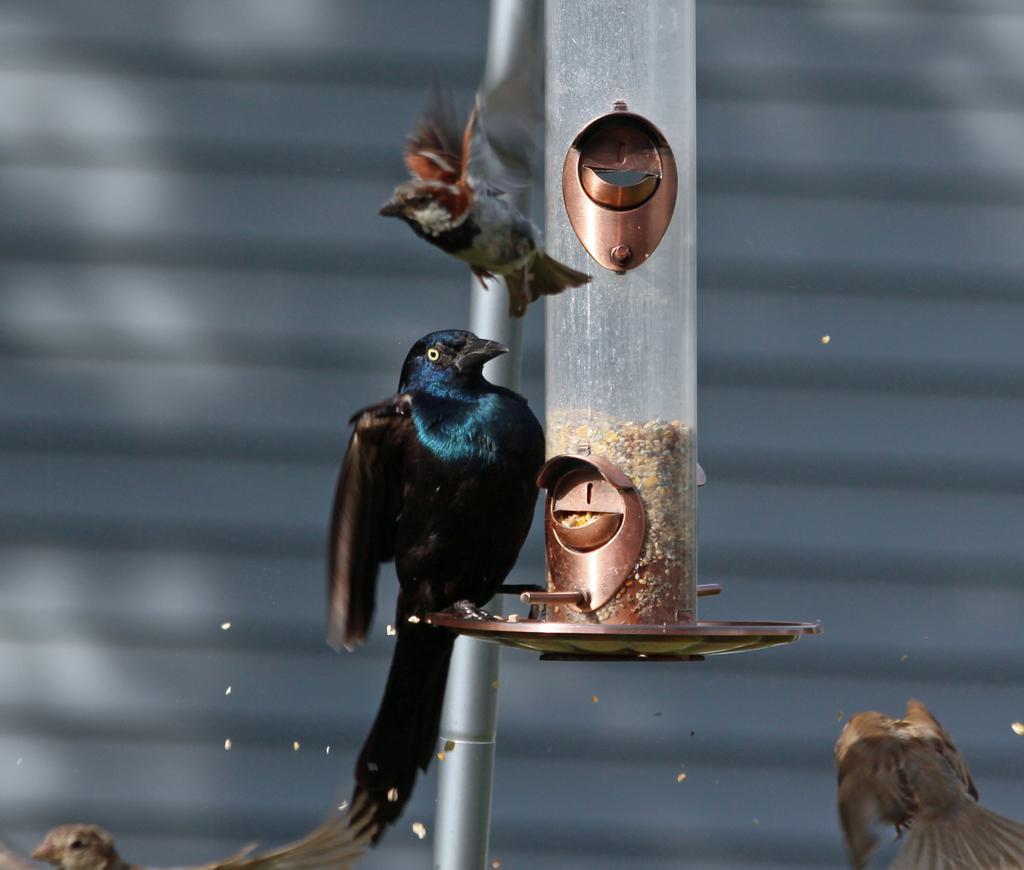Describe this image in one or two sentences. In this image we can see a bird on the stand of a bird feeder. We can also see a pole and some birds. 